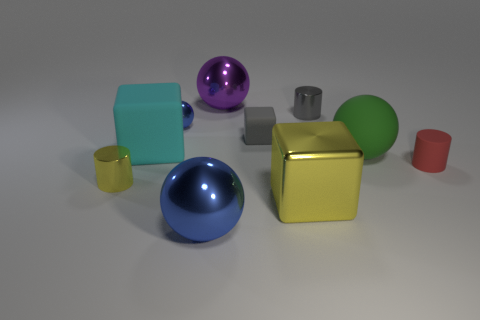Is the number of large green matte balls on the right side of the green matte thing greater than the number of tiny gray matte objects?
Provide a succinct answer. No. How many gray objects are behind the matte block that is behind the large cyan rubber cube that is behind the yellow metallic cylinder?
Your answer should be compact. 1. There is a blue shiny object in front of the tiny blue metallic ball; is it the same size as the yellow object that is on the right side of the large blue metal sphere?
Your answer should be compact. Yes. What material is the cube that is in front of the tiny shiny cylinder in front of the small gray metallic cylinder?
Offer a very short reply. Metal. How many things are either blue shiny balls behind the big yellow metallic cube or cyan objects?
Offer a terse response. 2. Are there the same number of tiny metal cylinders that are in front of the large metal block and rubber objects that are behind the purple thing?
Ensure brevity in your answer.  Yes. There is a cylinder that is on the right side of the small metal cylinder that is behind the metal cylinder that is to the left of the big blue thing; what is its material?
Your answer should be compact. Rubber. What size is the cylinder that is both in front of the tiny gray shiny cylinder and right of the purple ball?
Your answer should be very brief. Small. Is the shape of the cyan thing the same as the purple metallic object?
Provide a succinct answer. No. The small gray thing that is the same material as the big purple sphere is what shape?
Your response must be concise. Cylinder. 